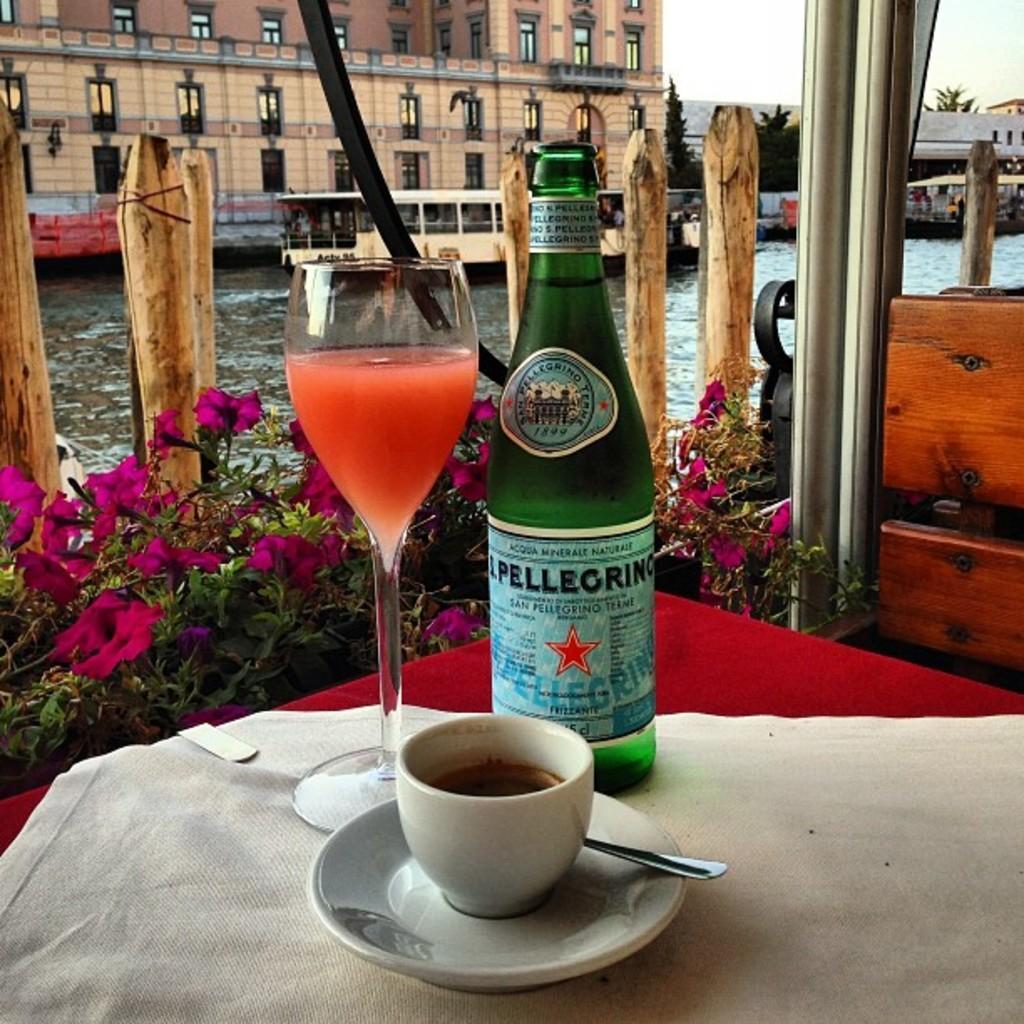In one or two sentences, can you explain what this image depicts? On the red color table there is a white cloth on it. On the table there is a cup with the saucer and spoon in it, behind the cup there is a green color bottle and and a glass with juice in it. In the background there is a building. In front of the building there is a water with boat on it. 